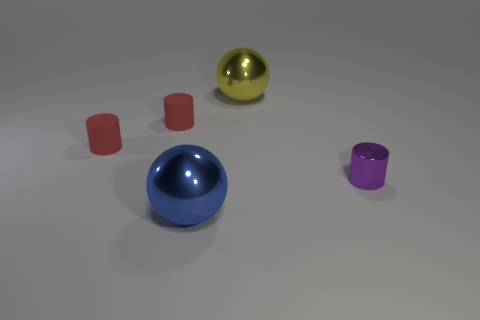Add 4 big gray rubber blocks. How many objects exist? 9 Subtract all cylinders. How many objects are left? 2 Add 1 big things. How many big things exist? 3 Subtract 0 brown blocks. How many objects are left? 5 Subtract all big yellow shiny balls. Subtract all red matte balls. How many objects are left? 4 Add 2 large blue metal spheres. How many large blue metal spheres are left? 3 